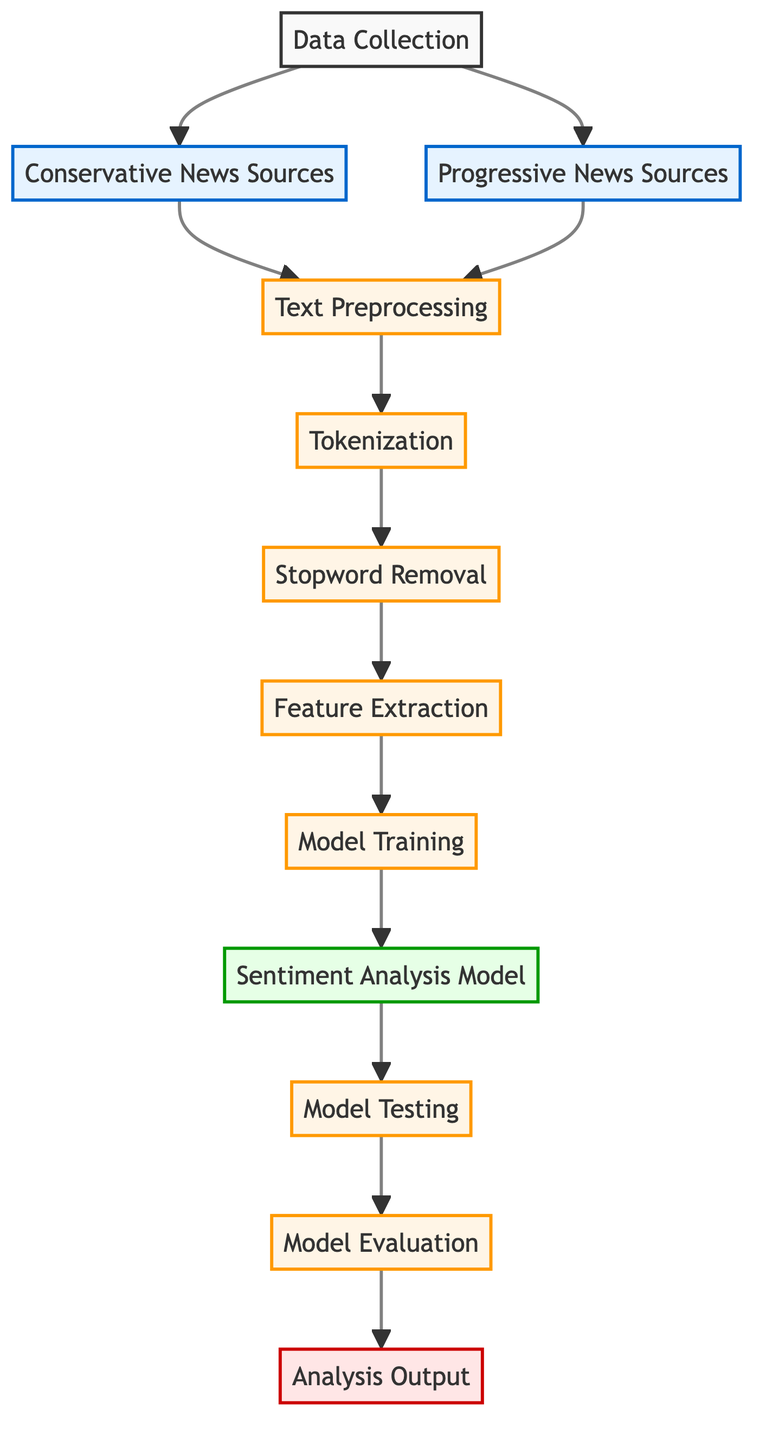What are the two sources of data in the diagram? The diagram shows two data sources which are "Conservative News Sources" and "Progressive News Sources." These nodes are connected to the main data collection node, indicating they are the inputs for the sentiment analysis process.
Answer: Conservative News Sources, Progressive News Sources How many processing steps are there in the diagram? The diagram outlines multiple processing steps after data collection. These include Text Preprocessing, Tokenization, Stopword Removal, Feature Extraction, Model Training, and Model Testing, totaling six processing steps.
Answer: 6 What is the output of the analysis process? At the end of the flowchart, the final node is labeled "Analysis Output," representing the result derived from the model evaluation. This indicates that the output of the entire process is the interpretation of the sentiment analysis.
Answer: Analysis Output Which node comes after Feature Extraction? The diagram has directed arrows indicating the sequence of the process. After the "Feature Extraction" node, the next step is "Model Training," showing the flow from one processed step to the next.
Answer: Model Training How many total nodes are there in the diagram? Counting all the distinct nodes in the diagram, there are 12 nodes in total, which include the data collection, its sources, processing steps, model components, and output node.
Answer: 12 What is the relationship between Model Testing and Model Evaluation? The diagram illustrates that "Model Testing" leads directly to "Model Evaluation," indicating that model evaluation is based on the results derived from testing the sentiment analysis model. This shows a sequential dependency in the diagram.
Answer: Directly connected What kind of model is being trained in this diagram? The diagram mentions "Sentiment Analysis Model" as the primary model being trained after the feature extraction step. This indicates the focus of the analysis is on sentiment.
Answer: Sentiment Analysis Model In which step do stopword removal occur? According to the flow of the diagram, "Stopword Removal" follows "Tokenization," making it the third step in the preprocessing phase of the sentiment analysis process.
Answer: After Tokenization 